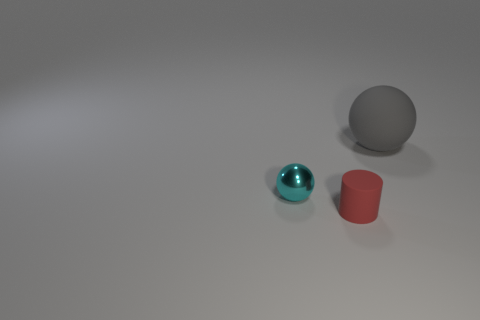Add 3 small cyan objects. How many objects exist? 6 Subtract all cylinders. How many objects are left? 2 Subtract 0 gray cylinders. How many objects are left? 3 Subtract all small blue matte balls. Subtract all gray matte things. How many objects are left? 2 Add 2 big gray things. How many big gray things are left? 3 Add 1 small cyan metallic things. How many small cyan metallic things exist? 2 